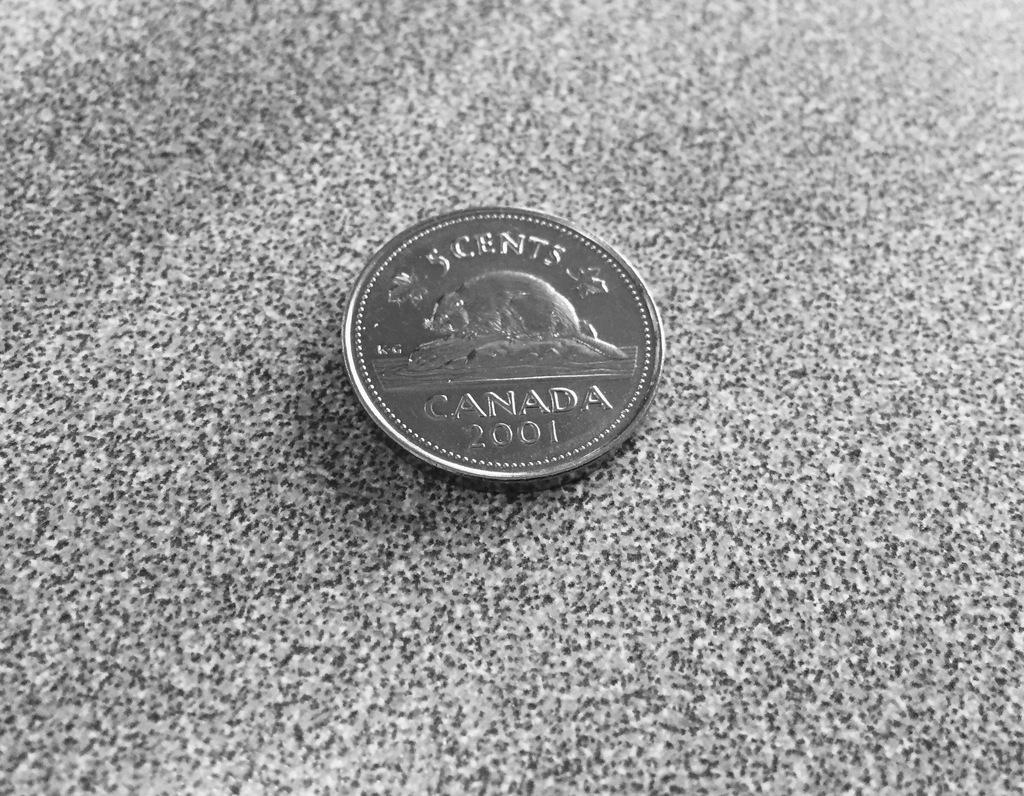<image>
Write a terse but informative summary of the picture. A five cent Canadian coin with the date 2001 on it 